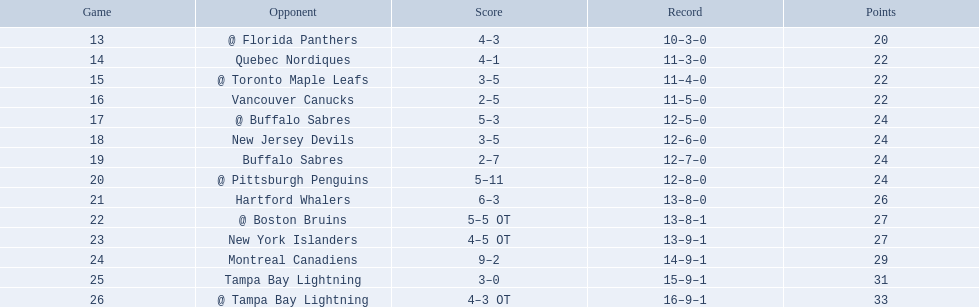What were the scores of the 1993-94 philadelphia flyers season? 4–3, 4–1, 3–5, 2–5, 5–3, 3–5, 2–7, 5–11, 6–3, 5–5 OT, 4–5 OT, 9–2, 3–0, 4–3 OT. Which of these teams had the score 4-5 ot? New York Islanders. 